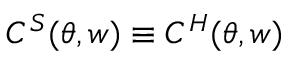<formula> <loc_0><loc_0><loc_500><loc_500>C ^ { S } ( \theta , w ) \equiv C ^ { H } ( \theta , w )</formula> 